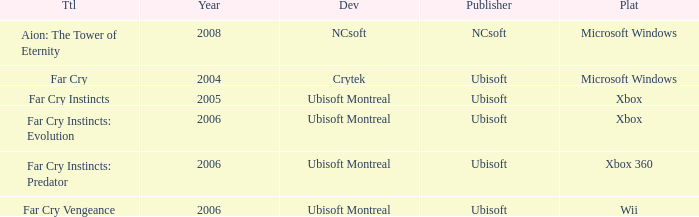Which game title was released before 2008 and is available on the xbox 360 platform? Far Cry Instincts: Predator. 